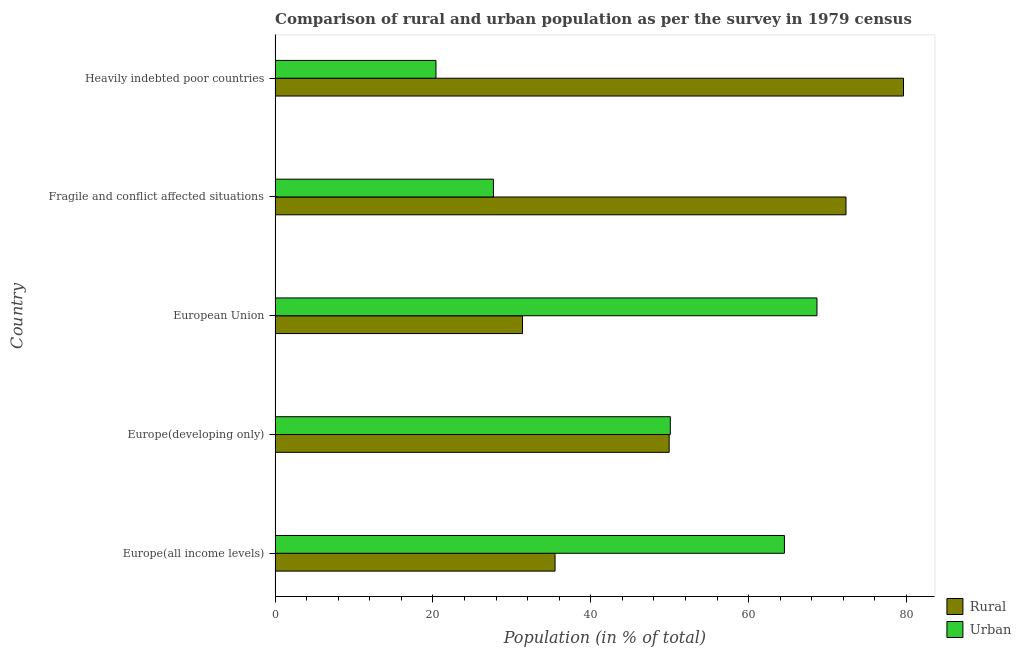How many different coloured bars are there?
Ensure brevity in your answer.  2. How many groups of bars are there?
Provide a succinct answer. 5. What is the label of the 1st group of bars from the top?
Provide a short and direct response. Heavily indebted poor countries. In how many cases, is the number of bars for a given country not equal to the number of legend labels?
Your response must be concise. 0. What is the rural population in Europe(developing only)?
Offer a terse response. 49.93. Across all countries, what is the maximum rural population?
Your answer should be very brief. 79.62. Across all countries, what is the minimum rural population?
Your response must be concise. 31.35. In which country was the rural population maximum?
Offer a very short reply. Heavily indebted poor countries. In which country was the urban population minimum?
Provide a succinct answer. Heavily indebted poor countries. What is the total urban population in the graph?
Offer a terse response. 231.31. What is the difference between the rural population in Europe(all income levels) and that in Heavily indebted poor countries?
Give a very brief answer. -44.15. What is the difference between the urban population in Europe(developing only) and the rural population in European Union?
Offer a very short reply. 18.73. What is the average urban population per country?
Your response must be concise. 46.26. What is the difference between the rural population and urban population in Heavily indebted poor countries?
Your response must be concise. 59.23. What is the ratio of the urban population in European Union to that in Fragile and conflict affected situations?
Your answer should be compact. 2.48. Is the urban population in Europe(developing only) less than that in Fragile and conflict affected situations?
Offer a very short reply. No. Is the difference between the urban population in Europe(developing only) and Heavily indebted poor countries greater than the difference between the rural population in Europe(developing only) and Heavily indebted poor countries?
Your answer should be very brief. Yes. What is the difference between the highest and the second highest rural population?
Your answer should be very brief. 7.28. What is the difference between the highest and the lowest rural population?
Offer a very short reply. 48.27. In how many countries, is the urban population greater than the average urban population taken over all countries?
Give a very brief answer. 3. What does the 1st bar from the top in Fragile and conflict affected situations represents?
Give a very brief answer. Urban. What does the 1st bar from the bottom in Heavily indebted poor countries represents?
Your answer should be very brief. Rural. Are all the bars in the graph horizontal?
Provide a succinct answer. Yes. How many countries are there in the graph?
Keep it short and to the point. 5. Are the values on the major ticks of X-axis written in scientific E-notation?
Ensure brevity in your answer.  No. Does the graph contain grids?
Offer a terse response. No. Where does the legend appear in the graph?
Make the answer very short. Bottom right. What is the title of the graph?
Your response must be concise. Comparison of rural and urban population as per the survey in 1979 census. Does "Attending school" appear as one of the legend labels in the graph?
Provide a succinct answer. No. What is the label or title of the X-axis?
Provide a short and direct response. Population (in % of total). What is the Population (in % of total) of Rural in Europe(all income levels)?
Provide a short and direct response. 35.47. What is the Population (in % of total) in Urban in Europe(all income levels)?
Make the answer very short. 64.53. What is the Population (in % of total) of Rural in Europe(developing only)?
Make the answer very short. 49.93. What is the Population (in % of total) in Urban in Europe(developing only)?
Provide a succinct answer. 50.07. What is the Population (in % of total) in Rural in European Union?
Keep it short and to the point. 31.35. What is the Population (in % of total) of Urban in European Union?
Your response must be concise. 68.65. What is the Population (in % of total) of Rural in Fragile and conflict affected situations?
Your answer should be compact. 72.33. What is the Population (in % of total) of Urban in Fragile and conflict affected situations?
Your response must be concise. 27.67. What is the Population (in % of total) in Rural in Heavily indebted poor countries?
Offer a very short reply. 79.62. What is the Population (in % of total) of Urban in Heavily indebted poor countries?
Make the answer very short. 20.38. Across all countries, what is the maximum Population (in % of total) of Rural?
Give a very brief answer. 79.62. Across all countries, what is the maximum Population (in % of total) of Urban?
Your answer should be very brief. 68.65. Across all countries, what is the minimum Population (in % of total) in Rural?
Offer a very short reply. 31.35. Across all countries, what is the minimum Population (in % of total) in Urban?
Provide a succinct answer. 20.38. What is the total Population (in % of total) of Rural in the graph?
Offer a very short reply. 268.69. What is the total Population (in % of total) in Urban in the graph?
Offer a very short reply. 231.31. What is the difference between the Population (in % of total) in Rural in Europe(all income levels) and that in Europe(developing only)?
Your answer should be very brief. -14.46. What is the difference between the Population (in % of total) of Urban in Europe(all income levels) and that in Europe(developing only)?
Provide a succinct answer. 14.46. What is the difference between the Population (in % of total) of Rural in Europe(all income levels) and that in European Union?
Give a very brief answer. 4.12. What is the difference between the Population (in % of total) of Urban in Europe(all income levels) and that in European Union?
Your response must be concise. -4.12. What is the difference between the Population (in % of total) of Rural in Europe(all income levels) and that in Fragile and conflict affected situations?
Provide a succinct answer. -36.86. What is the difference between the Population (in % of total) in Urban in Europe(all income levels) and that in Fragile and conflict affected situations?
Ensure brevity in your answer.  36.86. What is the difference between the Population (in % of total) in Rural in Europe(all income levels) and that in Heavily indebted poor countries?
Make the answer very short. -44.15. What is the difference between the Population (in % of total) in Urban in Europe(all income levels) and that in Heavily indebted poor countries?
Give a very brief answer. 44.15. What is the difference between the Population (in % of total) of Rural in Europe(developing only) and that in European Union?
Provide a succinct answer. 18.58. What is the difference between the Population (in % of total) of Urban in Europe(developing only) and that in European Union?
Your answer should be very brief. -18.58. What is the difference between the Population (in % of total) in Rural in Europe(developing only) and that in Fragile and conflict affected situations?
Your answer should be compact. -22.41. What is the difference between the Population (in % of total) of Urban in Europe(developing only) and that in Fragile and conflict affected situations?
Provide a short and direct response. 22.41. What is the difference between the Population (in % of total) in Rural in Europe(developing only) and that in Heavily indebted poor countries?
Provide a succinct answer. -29.69. What is the difference between the Population (in % of total) in Urban in Europe(developing only) and that in Heavily indebted poor countries?
Ensure brevity in your answer.  29.69. What is the difference between the Population (in % of total) in Rural in European Union and that in Fragile and conflict affected situations?
Ensure brevity in your answer.  -40.99. What is the difference between the Population (in % of total) in Urban in European Union and that in Fragile and conflict affected situations?
Make the answer very short. 40.99. What is the difference between the Population (in % of total) in Rural in European Union and that in Heavily indebted poor countries?
Ensure brevity in your answer.  -48.27. What is the difference between the Population (in % of total) in Urban in European Union and that in Heavily indebted poor countries?
Provide a succinct answer. 48.27. What is the difference between the Population (in % of total) of Rural in Fragile and conflict affected situations and that in Heavily indebted poor countries?
Make the answer very short. -7.28. What is the difference between the Population (in % of total) in Urban in Fragile and conflict affected situations and that in Heavily indebted poor countries?
Make the answer very short. 7.28. What is the difference between the Population (in % of total) in Rural in Europe(all income levels) and the Population (in % of total) in Urban in Europe(developing only)?
Your response must be concise. -14.6. What is the difference between the Population (in % of total) of Rural in Europe(all income levels) and the Population (in % of total) of Urban in European Union?
Give a very brief answer. -33.18. What is the difference between the Population (in % of total) of Rural in Europe(all income levels) and the Population (in % of total) of Urban in Fragile and conflict affected situations?
Give a very brief answer. 7.8. What is the difference between the Population (in % of total) in Rural in Europe(all income levels) and the Population (in % of total) in Urban in Heavily indebted poor countries?
Offer a terse response. 15.09. What is the difference between the Population (in % of total) of Rural in Europe(developing only) and the Population (in % of total) of Urban in European Union?
Your answer should be compact. -18.73. What is the difference between the Population (in % of total) of Rural in Europe(developing only) and the Population (in % of total) of Urban in Fragile and conflict affected situations?
Make the answer very short. 22.26. What is the difference between the Population (in % of total) of Rural in Europe(developing only) and the Population (in % of total) of Urban in Heavily indebted poor countries?
Keep it short and to the point. 29.54. What is the difference between the Population (in % of total) of Rural in European Union and the Population (in % of total) of Urban in Fragile and conflict affected situations?
Your response must be concise. 3.68. What is the difference between the Population (in % of total) of Rural in European Union and the Population (in % of total) of Urban in Heavily indebted poor countries?
Make the answer very short. 10.96. What is the difference between the Population (in % of total) in Rural in Fragile and conflict affected situations and the Population (in % of total) in Urban in Heavily indebted poor countries?
Your answer should be very brief. 51.95. What is the average Population (in % of total) of Rural per country?
Give a very brief answer. 53.74. What is the average Population (in % of total) of Urban per country?
Your answer should be compact. 46.26. What is the difference between the Population (in % of total) in Rural and Population (in % of total) in Urban in Europe(all income levels)?
Make the answer very short. -29.06. What is the difference between the Population (in % of total) in Rural and Population (in % of total) in Urban in Europe(developing only)?
Provide a succinct answer. -0.15. What is the difference between the Population (in % of total) of Rural and Population (in % of total) of Urban in European Union?
Your response must be concise. -37.31. What is the difference between the Population (in % of total) in Rural and Population (in % of total) in Urban in Fragile and conflict affected situations?
Your response must be concise. 44.66. What is the difference between the Population (in % of total) of Rural and Population (in % of total) of Urban in Heavily indebted poor countries?
Your response must be concise. 59.23. What is the ratio of the Population (in % of total) of Rural in Europe(all income levels) to that in Europe(developing only)?
Provide a succinct answer. 0.71. What is the ratio of the Population (in % of total) of Urban in Europe(all income levels) to that in Europe(developing only)?
Keep it short and to the point. 1.29. What is the ratio of the Population (in % of total) in Rural in Europe(all income levels) to that in European Union?
Ensure brevity in your answer.  1.13. What is the ratio of the Population (in % of total) of Urban in Europe(all income levels) to that in European Union?
Provide a short and direct response. 0.94. What is the ratio of the Population (in % of total) in Rural in Europe(all income levels) to that in Fragile and conflict affected situations?
Offer a terse response. 0.49. What is the ratio of the Population (in % of total) in Urban in Europe(all income levels) to that in Fragile and conflict affected situations?
Make the answer very short. 2.33. What is the ratio of the Population (in % of total) of Rural in Europe(all income levels) to that in Heavily indebted poor countries?
Offer a terse response. 0.45. What is the ratio of the Population (in % of total) of Urban in Europe(all income levels) to that in Heavily indebted poor countries?
Make the answer very short. 3.17. What is the ratio of the Population (in % of total) in Rural in Europe(developing only) to that in European Union?
Your answer should be compact. 1.59. What is the ratio of the Population (in % of total) in Urban in Europe(developing only) to that in European Union?
Offer a very short reply. 0.73. What is the ratio of the Population (in % of total) in Rural in Europe(developing only) to that in Fragile and conflict affected situations?
Offer a terse response. 0.69. What is the ratio of the Population (in % of total) in Urban in Europe(developing only) to that in Fragile and conflict affected situations?
Provide a short and direct response. 1.81. What is the ratio of the Population (in % of total) in Rural in Europe(developing only) to that in Heavily indebted poor countries?
Offer a very short reply. 0.63. What is the ratio of the Population (in % of total) in Urban in Europe(developing only) to that in Heavily indebted poor countries?
Keep it short and to the point. 2.46. What is the ratio of the Population (in % of total) in Rural in European Union to that in Fragile and conflict affected situations?
Ensure brevity in your answer.  0.43. What is the ratio of the Population (in % of total) in Urban in European Union to that in Fragile and conflict affected situations?
Give a very brief answer. 2.48. What is the ratio of the Population (in % of total) in Rural in European Union to that in Heavily indebted poor countries?
Your answer should be compact. 0.39. What is the ratio of the Population (in % of total) in Urban in European Union to that in Heavily indebted poor countries?
Your response must be concise. 3.37. What is the ratio of the Population (in % of total) in Rural in Fragile and conflict affected situations to that in Heavily indebted poor countries?
Your answer should be very brief. 0.91. What is the ratio of the Population (in % of total) of Urban in Fragile and conflict affected situations to that in Heavily indebted poor countries?
Offer a terse response. 1.36. What is the difference between the highest and the second highest Population (in % of total) in Rural?
Make the answer very short. 7.28. What is the difference between the highest and the second highest Population (in % of total) of Urban?
Offer a very short reply. 4.12. What is the difference between the highest and the lowest Population (in % of total) of Rural?
Your answer should be very brief. 48.27. What is the difference between the highest and the lowest Population (in % of total) of Urban?
Your response must be concise. 48.27. 